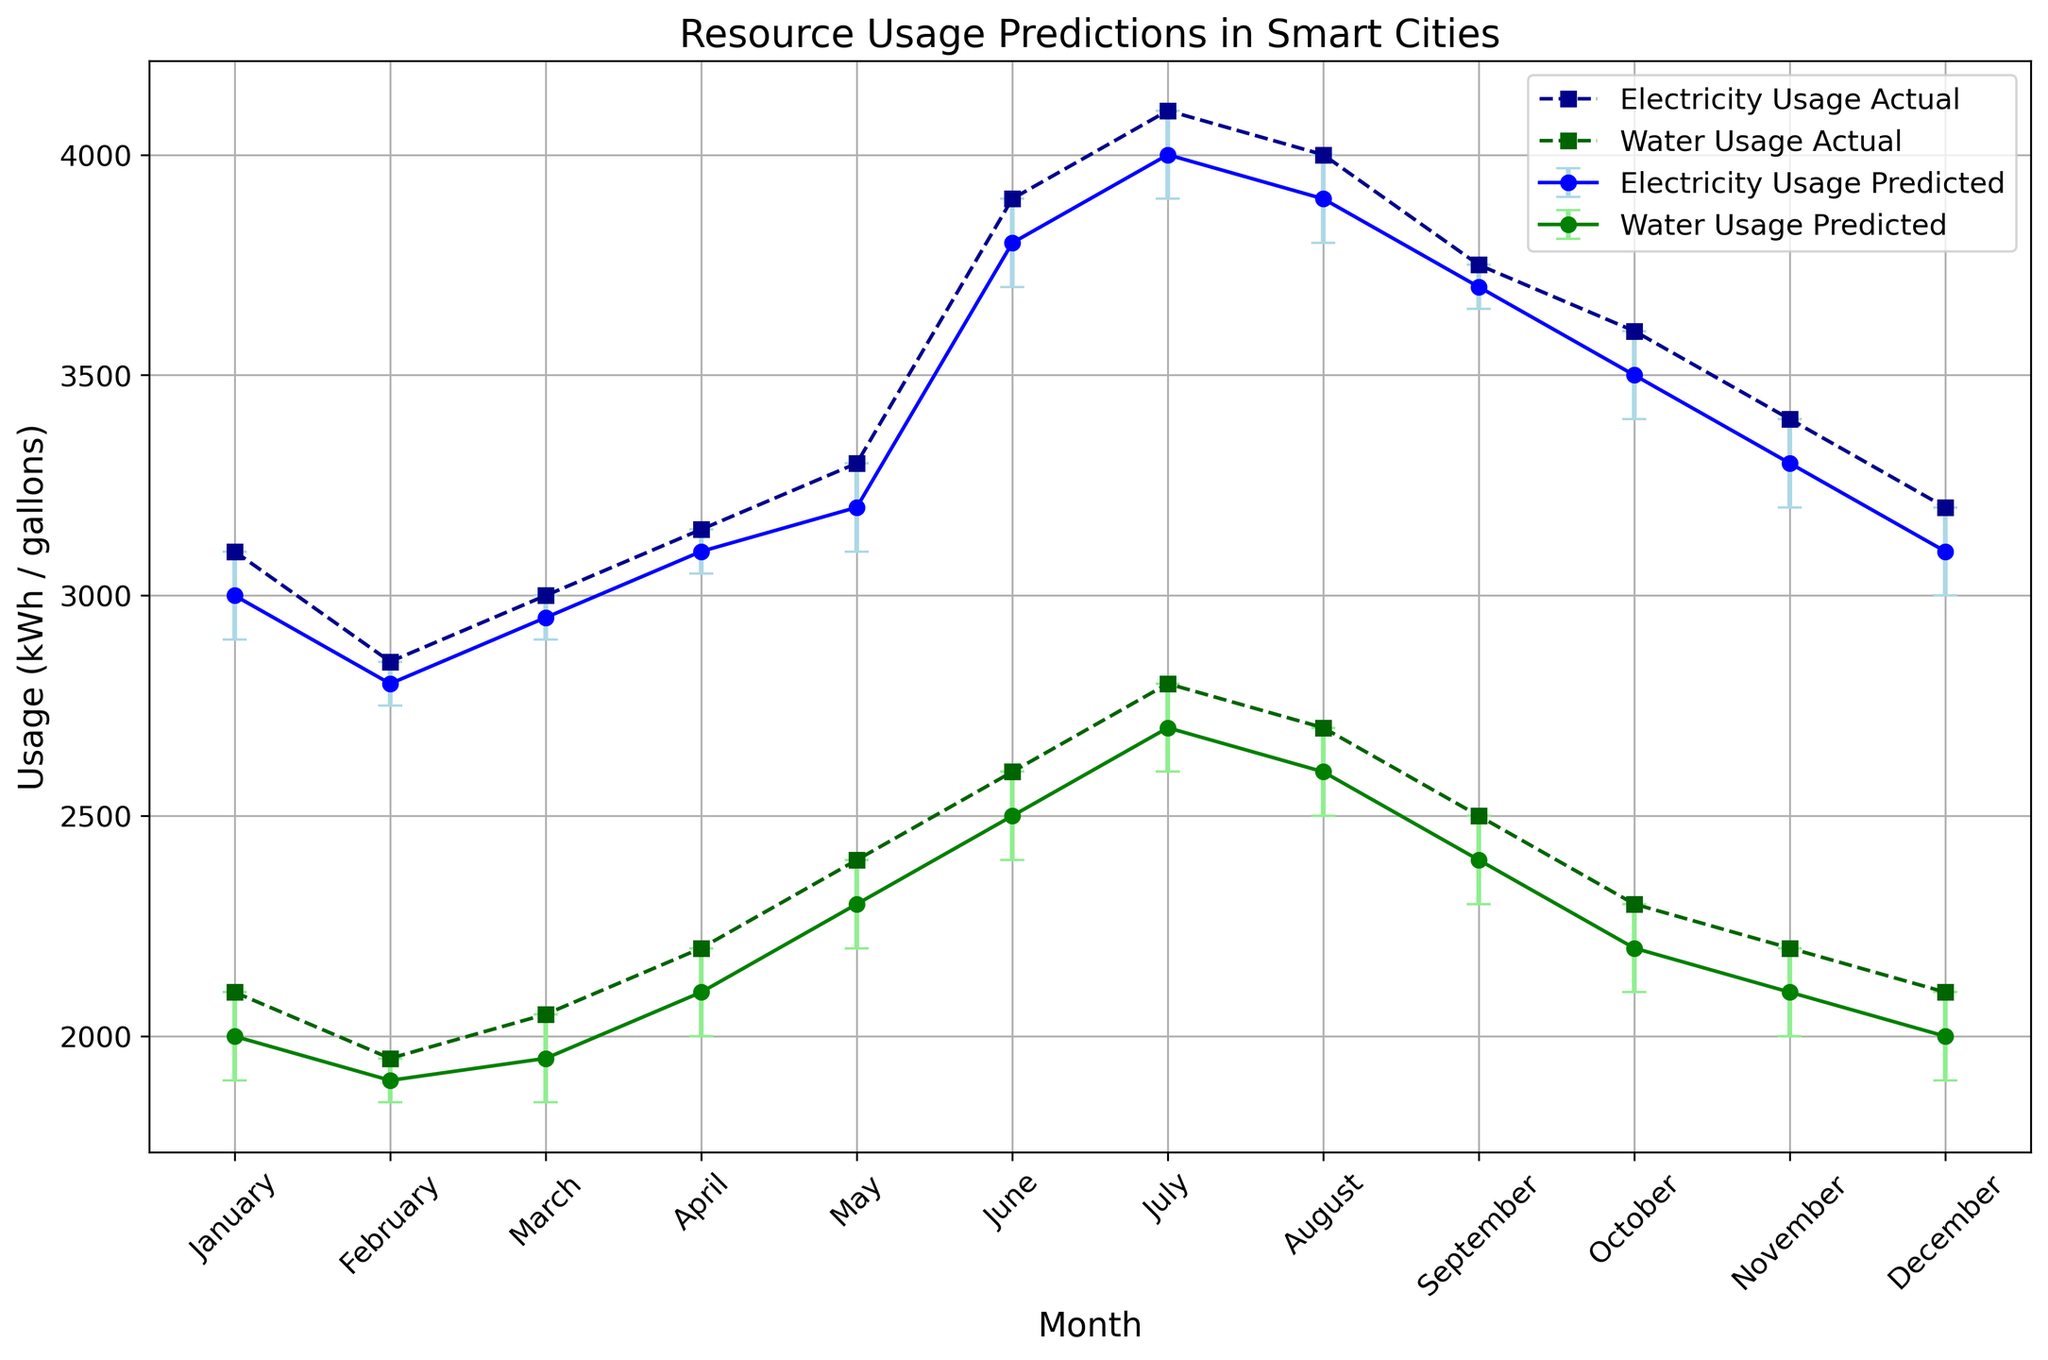What month shows the largest discrepancy between predicted and actual electricity usage? To find the month with the largest discrepancy, look at the difference between the predicted and actual values of electricity usage for each month. The largest difference occurs in January, where the predicted usage is 3000 kWh, and the actual usage is 3100 kWh.
Answer: January In which month do the predicted water usage values and actual usage values match least closely? To determine this, examine the difference between predicted and actual water usage values. May shows the largest discrepancy, with predicted usage at 2300 gallons and actual usage at 2400 gallons.
Answer: May When was the predicted electricity usage exactly 3800 kWh? Look for the month where the predicted electricity usage line or point hits 3800 kWh. This occurs in June.
Answer: June On average, how much higher is the actual water usage compared to the predicted values across all months? Calculate the difference for each month: (100+50+100+100+100+100+100+100+100+100+100+100), which sums to 1200 gallons. There are 12 months, so the average difference per month is 1200/12 = 100 gallons.
Answer: 100 gallons Does the month of August show a higher electricity usage compared to the month of April? Compare the actual electricity usage values for August (4000 kWh) and April (3150 kWh). August's value is higher.
Answer: Yes Which month has the least error in predicted electricity usage? Examine the error bars for electricity prediction. February, March, and April each have the smallest error of 50 kWh.
Answer: February, March, April In which month is the actual water usage the lowest? Identify the month with the smallest actual water usage value. January and December have the lowest value of 2100 gallons each.
Answer: January, December How does the trend of actual electricity usage compare between January and December? From January's 3100 kWh to December's 3200 kWh, actual electricity usage shows a slight increase.
Answer: Slight increase In which month do both the electricity and water predicted usage values peak? Look for the highest points on the predicted lines for both electricity and water usage. Electricity usage peaks in July with 4000 kWh, and water usage peaks in July with 2700 gallons.
Answer: July 